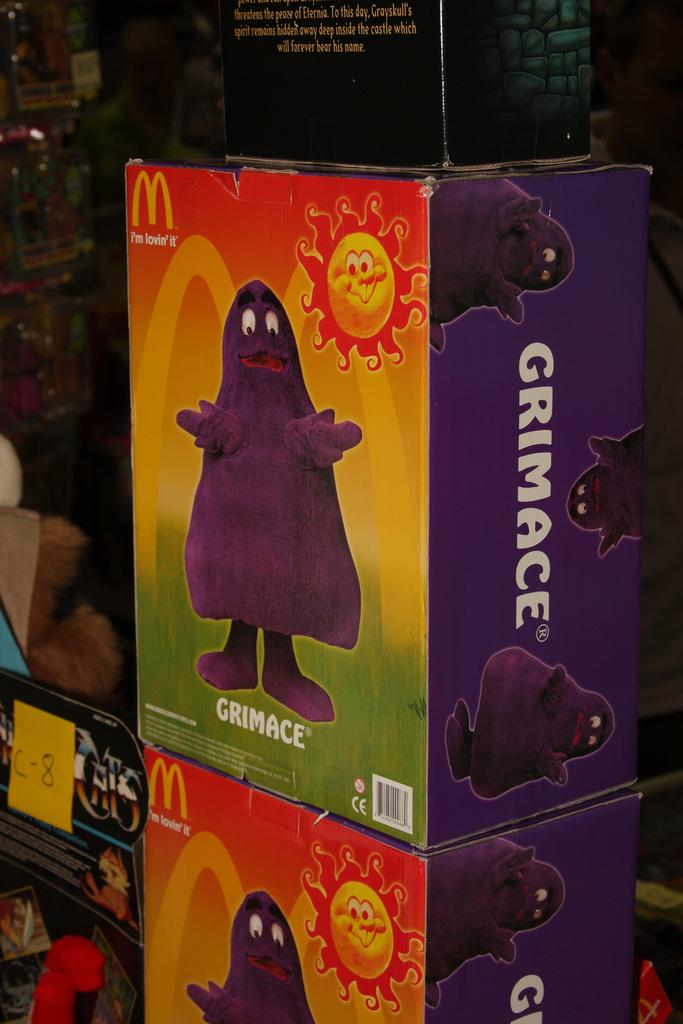<image>
Relay a brief, clear account of the picture shown. Boxes of McDonald's Grimace toys on the shelf. 